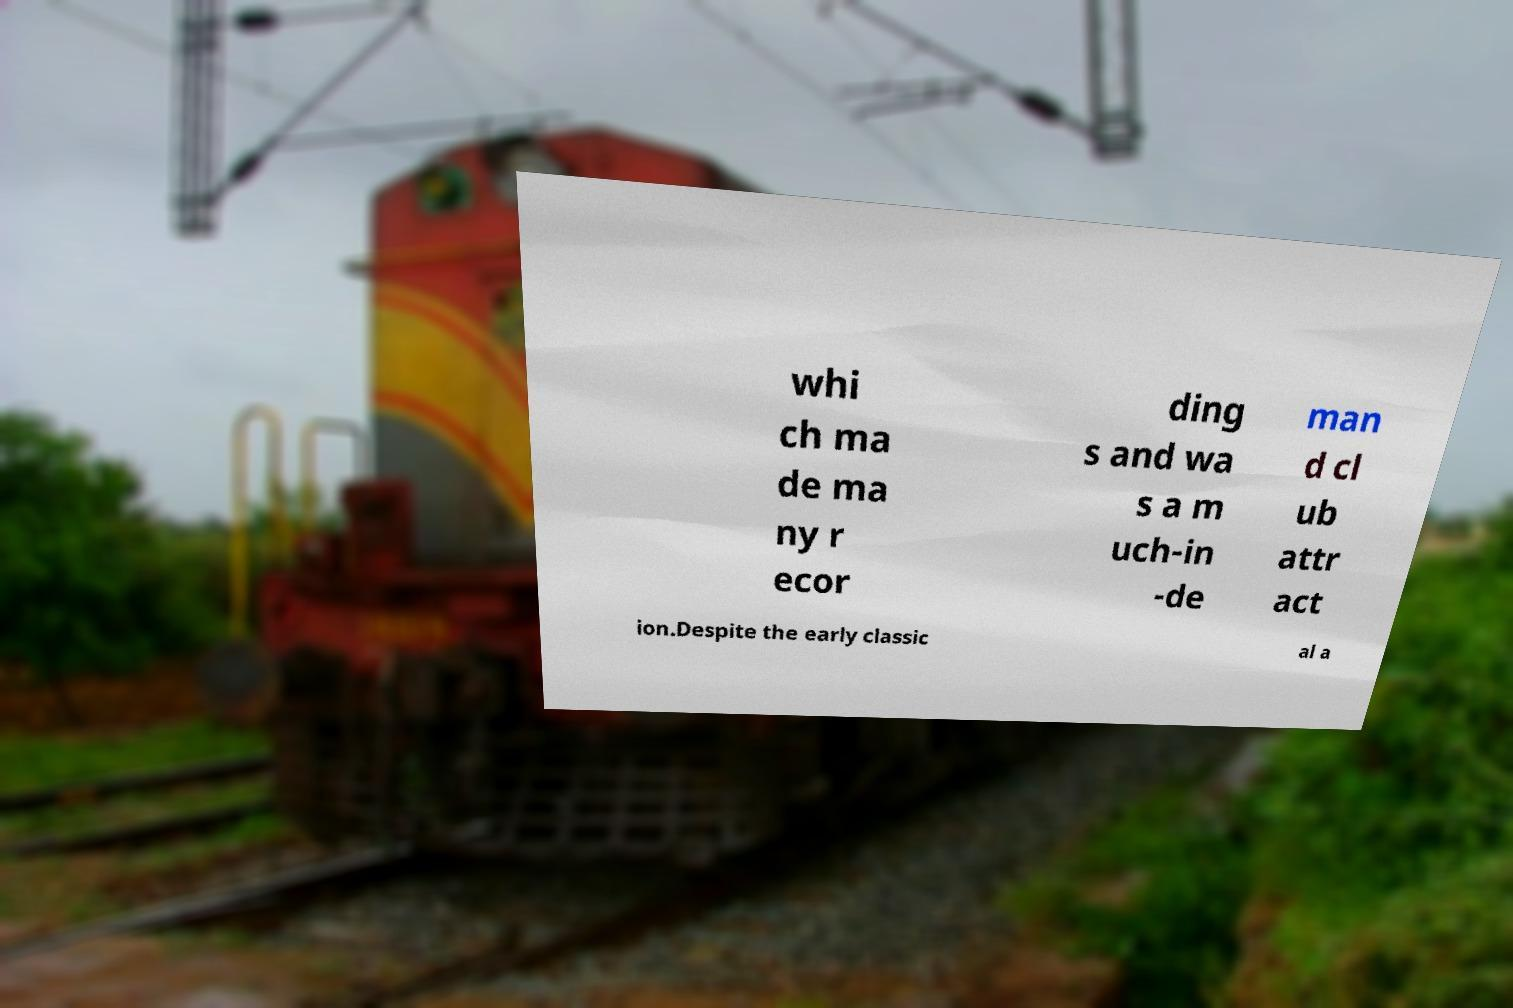Please read and relay the text visible in this image. What does it say? whi ch ma de ma ny r ecor ding s and wa s a m uch-in -de man d cl ub attr act ion.Despite the early classic al a 